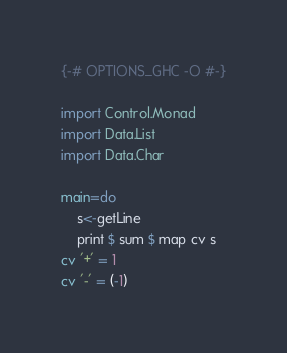Convert code to text. <code><loc_0><loc_0><loc_500><loc_500><_Haskell_>{-# OPTIONS_GHC -O #-}

import Control.Monad
import Data.List
import Data.Char

main=do
    s<-getLine
    print $ sum $ map cv s
cv '+' = 1
cv '-' = (-1)</code> 